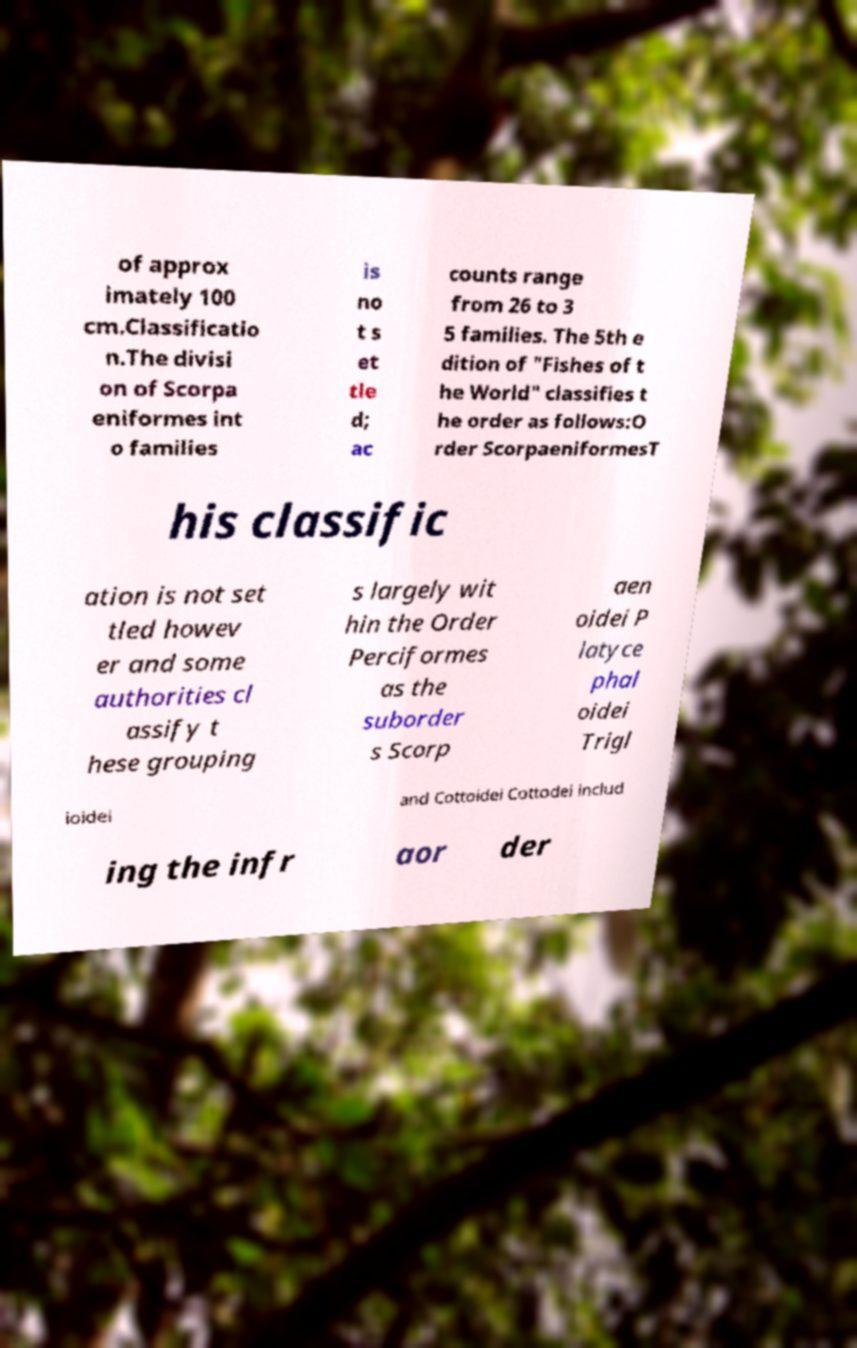There's text embedded in this image that I need extracted. Can you transcribe it verbatim? of approx imately 100 cm.Classificatio n.The divisi on of Scorpa eniformes int o families is no t s et tle d; ac counts range from 26 to 3 5 families. The 5th e dition of "Fishes of t he World" classifies t he order as follows:O rder ScorpaeniformesT his classific ation is not set tled howev er and some authorities cl assify t hese grouping s largely wit hin the Order Perciformes as the suborder s Scorp aen oidei P latyce phal oidei Trigl ioidei and Cottoidei Cottodei includ ing the infr aor der 